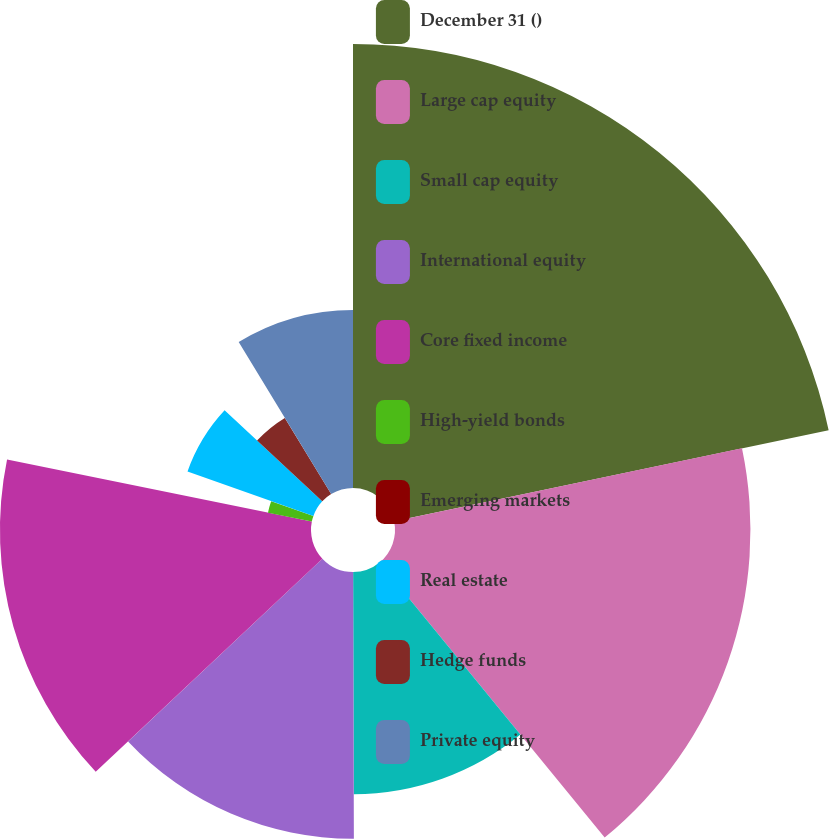Convert chart. <chart><loc_0><loc_0><loc_500><loc_500><pie_chart><fcel>December 31 ()<fcel>Large cap equity<fcel>Small cap equity<fcel>International equity<fcel>Core fixed income<fcel>High-yield bonds<fcel>Emerging markets<fcel>Real estate<fcel>Hedge funds<fcel>Private equity<nl><fcel>21.71%<fcel>17.38%<fcel>10.87%<fcel>13.04%<fcel>15.21%<fcel>2.19%<fcel>0.02%<fcel>6.53%<fcel>4.36%<fcel>8.7%<nl></chart> 